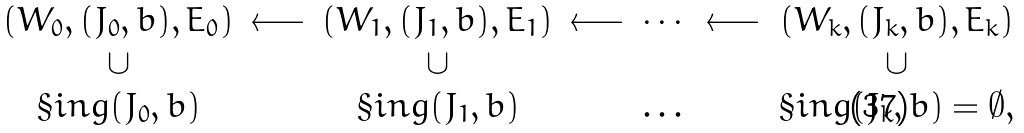<formula> <loc_0><loc_0><loc_500><loc_500>\begin{array} { c c c c c c c } ( W _ { 0 } , ( J _ { 0 } , b ) , E _ { 0 } ) & \longleftarrow & ( W _ { 1 } , ( J _ { 1 } , b ) , E _ { 1 } ) & \longleftarrow & \cdots & \longleftarrow & ( W _ { k } , ( J _ { k } , b ) , E _ { k } ) \\ \cup & & \cup & & & & \cup \\ \S i n g ( J _ { 0 } , b ) & & \S i n g ( J _ { 1 } , b ) & & \dots & & \S i n g ( J _ { k } , b ) = \emptyset , \end{array}</formula> 